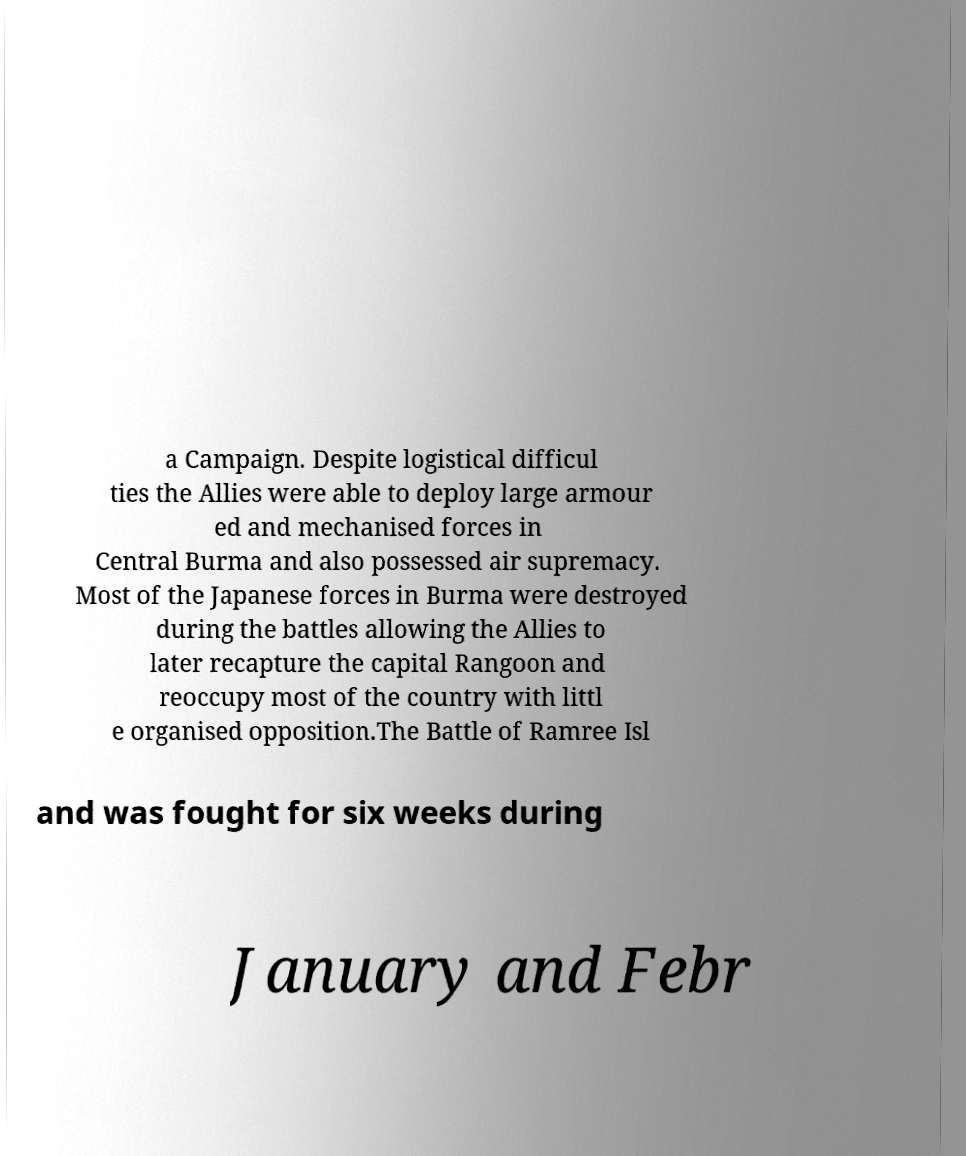Can you read and provide the text displayed in the image?This photo seems to have some interesting text. Can you extract and type it out for me? a Campaign. Despite logistical difficul ties the Allies were able to deploy large armour ed and mechanised forces in Central Burma and also possessed air supremacy. Most of the Japanese forces in Burma were destroyed during the battles allowing the Allies to later recapture the capital Rangoon and reoccupy most of the country with littl e organised opposition.The Battle of Ramree Isl and was fought for six weeks during January and Febr 